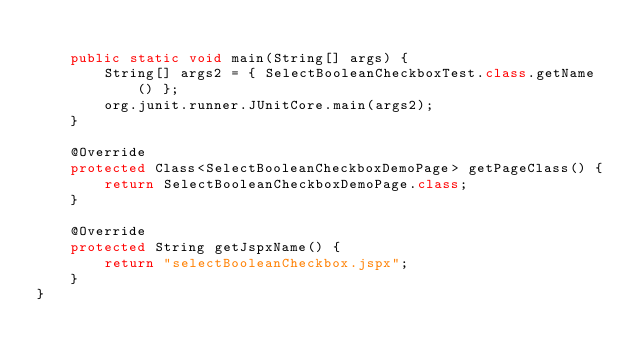<code> <loc_0><loc_0><loc_500><loc_500><_Java_>
    public static void main(String[] args) {
        String[] args2 = { SelectBooleanCheckboxTest.class.getName() };
        org.junit.runner.JUnitCore.main(args2);
    }

    @Override
    protected Class<SelectBooleanCheckboxDemoPage> getPageClass() {
        return SelectBooleanCheckboxDemoPage.class;
    }

    @Override
    protected String getJspxName() {
        return "selectBooleanCheckbox.jspx";
    }
}
</code> 